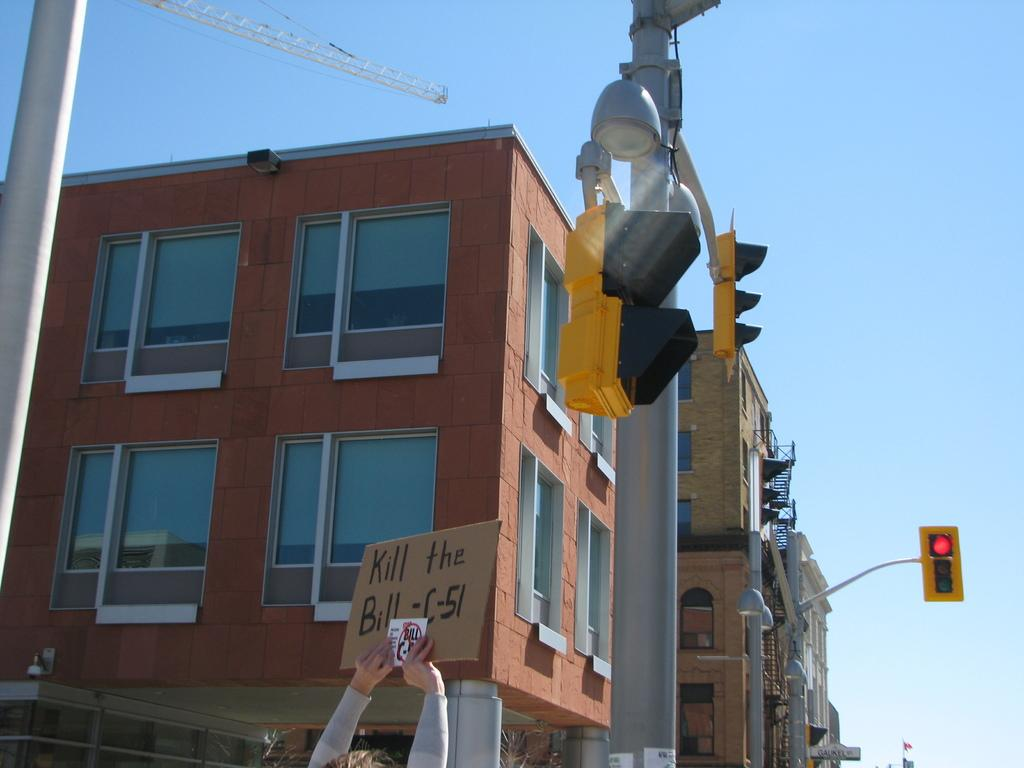<image>
Create a compact narrative representing the image presented. A person holding up a sign saying Kill the Bill C-51 